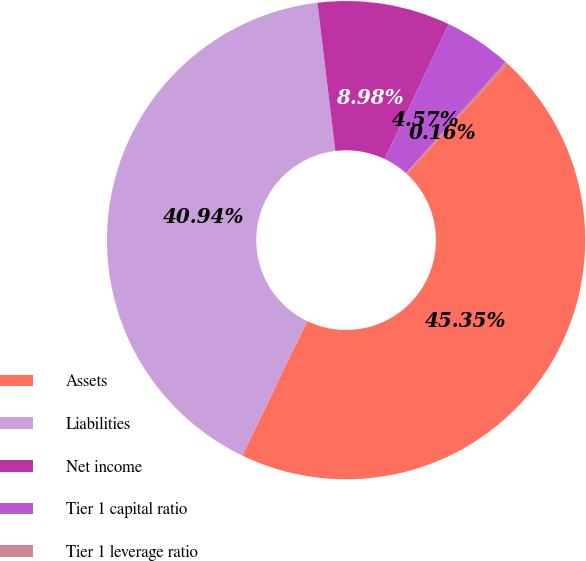<chart> <loc_0><loc_0><loc_500><loc_500><pie_chart><fcel>Assets<fcel>Liabilities<fcel>Net income<fcel>Tier 1 capital ratio<fcel>Tier 1 leverage ratio<nl><fcel>45.35%<fcel>40.94%<fcel>8.98%<fcel>4.57%<fcel>0.16%<nl></chart> 